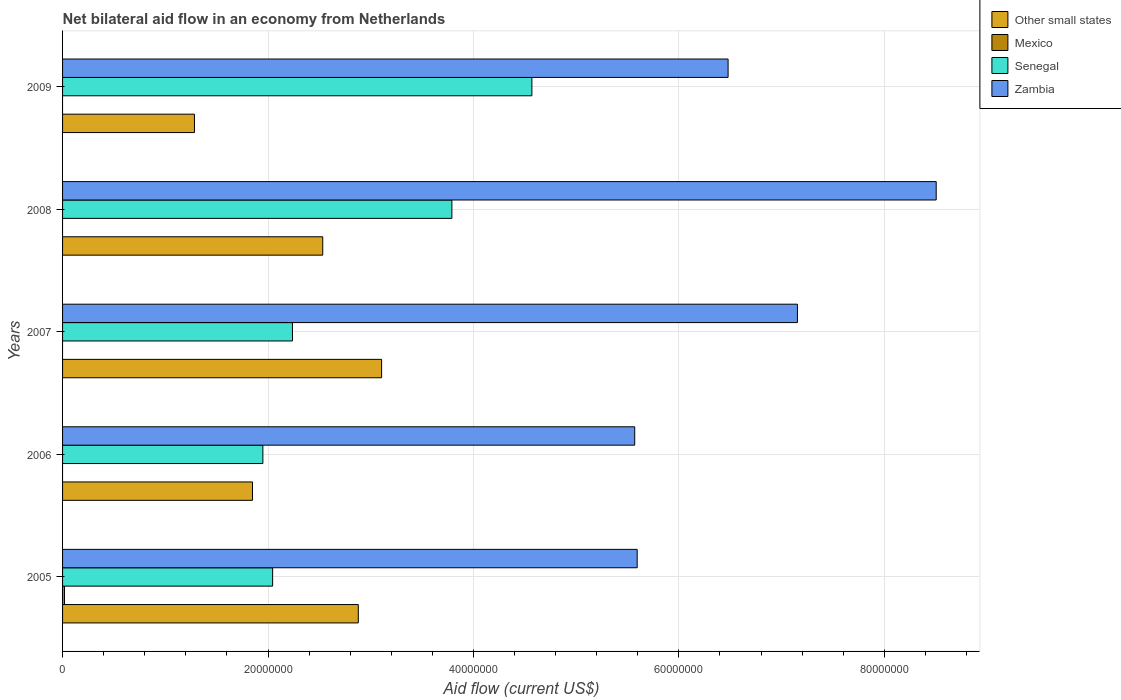Are the number of bars per tick equal to the number of legend labels?
Give a very brief answer. No. Are the number of bars on each tick of the Y-axis equal?
Ensure brevity in your answer.  No. In how many cases, is the number of bars for a given year not equal to the number of legend labels?
Make the answer very short. 4. Across all years, what is the maximum net bilateral aid flow in Mexico?
Give a very brief answer. 1.90e+05. Across all years, what is the minimum net bilateral aid flow in Mexico?
Your answer should be compact. 0. What is the total net bilateral aid flow in Senegal in the graph?
Give a very brief answer. 1.46e+08. What is the difference between the net bilateral aid flow in Zambia in 2005 and that in 2006?
Make the answer very short. 2.40e+05. What is the difference between the net bilateral aid flow in Zambia in 2006 and the net bilateral aid flow in Senegal in 2005?
Provide a succinct answer. 3.52e+07. What is the average net bilateral aid flow in Senegal per year?
Keep it short and to the point. 2.92e+07. In the year 2005, what is the difference between the net bilateral aid flow in Other small states and net bilateral aid flow in Senegal?
Keep it short and to the point. 8.34e+06. In how many years, is the net bilateral aid flow in Senegal greater than 40000000 US$?
Provide a short and direct response. 1. What is the ratio of the net bilateral aid flow in Senegal in 2005 to that in 2009?
Provide a short and direct response. 0.45. Is the net bilateral aid flow in Senegal in 2006 less than that in 2008?
Give a very brief answer. Yes. What is the difference between the highest and the second highest net bilateral aid flow in Zambia?
Ensure brevity in your answer.  1.35e+07. What is the difference between the highest and the lowest net bilateral aid flow in Senegal?
Ensure brevity in your answer.  2.62e+07. Is the sum of the net bilateral aid flow in Senegal in 2005 and 2006 greater than the maximum net bilateral aid flow in Mexico across all years?
Keep it short and to the point. Yes. Is it the case that in every year, the sum of the net bilateral aid flow in Mexico and net bilateral aid flow in Other small states is greater than the net bilateral aid flow in Senegal?
Make the answer very short. No. Are all the bars in the graph horizontal?
Keep it short and to the point. Yes. Does the graph contain any zero values?
Your response must be concise. Yes. How many legend labels are there?
Give a very brief answer. 4. How are the legend labels stacked?
Your answer should be very brief. Vertical. What is the title of the graph?
Keep it short and to the point. Net bilateral aid flow in an economy from Netherlands. Does "Guatemala" appear as one of the legend labels in the graph?
Your response must be concise. No. What is the label or title of the X-axis?
Provide a short and direct response. Aid flow (current US$). What is the Aid flow (current US$) in Other small states in 2005?
Your answer should be very brief. 2.88e+07. What is the Aid flow (current US$) of Mexico in 2005?
Keep it short and to the point. 1.90e+05. What is the Aid flow (current US$) of Senegal in 2005?
Provide a short and direct response. 2.04e+07. What is the Aid flow (current US$) of Zambia in 2005?
Provide a short and direct response. 5.59e+07. What is the Aid flow (current US$) of Other small states in 2006?
Your response must be concise. 1.85e+07. What is the Aid flow (current US$) in Senegal in 2006?
Keep it short and to the point. 1.95e+07. What is the Aid flow (current US$) of Zambia in 2006?
Your answer should be compact. 5.57e+07. What is the Aid flow (current US$) in Other small states in 2007?
Make the answer very short. 3.11e+07. What is the Aid flow (current US$) of Senegal in 2007?
Provide a short and direct response. 2.24e+07. What is the Aid flow (current US$) in Zambia in 2007?
Provide a succinct answer. 7.15e+07. What is the Aid flow (current US$) in Other small states in 2008?
Your response must be concise. 2.53e+07. What is the Aid flow (current US$) of Mexico in 2008?
Give a very brief answer. 0. What is the Aid flow (current US$) of Senegal in 2008?
Provide a succinct answer. 3.79e+07. What is the Aid flow (current US$) of Zambia in 2008?
Offer a very short reply. 8.50e+07. What is the Aid flow (current US$) in Other small states in 2009?
Ensure brevity in your answer.  1.28e+07. What is the Aid flow (current US$) of Senegal in 2009?
Ensure brevity in your answer.  4.57e+07. What is the Aid flow (current US$) of Zambia in 2009?
Offer a terse response. 6.48e+07. Across all years, what is the maximum Aid flow (current US$) in Other small states?
Provide a short and direct response. 3.11e+07. Across all years, what is the maximum Aid flow (current US$) in Mexico?
Your answer should be very brief. 1.90e+05. Across all years, what is the maximum Aid flow (current US$) of Senegal?
Provide a short and direct response. 4.57e+07. Across all years, what is the maximum Aid flow (current US$) of Zambia?
Offer a terse response. 8.50e+07. Across all years, what is the minimum Aid flow (current US$) in Other small states?
Keep it short and to the point. 1.28e+07. Across all years, what is the minimum Aid flow (current US$) in Mexico?
Your answer should be very brief. 0. Across all years, what is the minimum Aid flow (current US$) of Senegal?
Offer a terse response. 1.95e+07. Across all years, what is the minimum Aid flow (current US$) in Zambia?
Keep it short and to the point. 5.57e+07. What is the total Aid flow (current US$) in Other small states in the graph?
Provide a succinct answer. 1.17e+08. What is the total Aid flow (current US$) of Senegal in the graph?
Give a very brief answer. 1.46e+08. What is the total Aid flow (current US$) of Zambia in the graph?
Make the answer very short. 3.33e+08. What is the difference between the Aid flow (current US$) in Other small states in 2005 and that in 2006?
Provide a short and direct response. 1.03e+07. What is the difference between the Aid flow (current US$) of Senegal in 2005 and that in 2006?
Provide a short and direct response. 9.50e+05. What is the difference between the Aid flow (current US$) of Zambia in 2005 and that in 2006?
Your response must be concise. 2.40e+05. What is the difference between the Aid flow (current US$) of Other small states in 2005 and that in 2007?
Ensure brevity in your answer.  -2.27e+06. What is the difference between the Aid flow (current US$) in Senegal in 2005 and that in 2007?
Your answer should be compact. -1.93e+06. What is the difference between the Aid flow (current US$) in Zambia in 2005 and that in 2007?
Your answer should be very brief. -1.56e+07. What is the difference between the Aid flow (current US$) in Other small states in 2005 and that in 2008?
Ensure brevity in your answer.  3.46e+06. What is the difference between the Aid flow (current US$) in Senegal in 2005 and that in 2008?
Provide a short and direct response. -1.74e+07. What is the difference between the Aid flow (current US$) of Zambia in 2005 and that in 2008?
Your answer should be very brief. -2.91e+07. What is the difference between the Aid flow (current US$) in Other small states in 2005 and that in 2009?
Offer a very short reply. 1.60e+07. What is the difference between the Aid flow (current US$) in Senegal in 2005 and that in 2009?
Ensure brevity in your answer.  -2.52e+07. What is the difference between the Aid flow (current US$) of Zambia in 2005 and that in 2009?
Ensure brevity in your answer.  -8.85e+06. What is the difference between the Aid flow (current US$) in Other small states in 2006 and that in 2007?
Your response must be concise. -1.26e+07. What is the difference between the Aid flow (current US$) in Senegal in 2006 and that in 2007?
Your response must be concise. -2.88e+06. What is the difference between the Aid flow (current US$) of Zambia in 2006 and that in 2007?
Keep it short and to the point. -1.58e+07. What is the difference between the Aid flow (current US$) of Other small states in 2006 and that in 2008?
Make the answer very short. -6.84e+06. What is the difference between the Aid flow (current US$) in Senegal in 2006 and that in 2008?
Your answer should be compact. -1.84e+07. What is the difference between the Aid flow (current US$) in Zambia in 2006 and that in 2008?
Your response must be concise. -2.94e+07. What is the difference between the Aid flow (current US$) in Other small states in 2006 and that in 2009?
Give a very brief answer. 5.65e+06. What is the difference between the Aid flow (current US$) in Senegal in 2006 and that in 2009?
Offer a very short reply. -2.62e+07. What is the difference between the Aid flow (current US$) of Zambia in 2006 and that in 2009?
Offer a terse response. -9.09e+06. What is the difference between the Aid flow (current US$) in Other small states in 2007 and that in 2008?
Your answer should be compact. 5.73e+06. What is the difference between the Aid flow (current US$) in Senegal in 2007 and that in 2008?
Offer a very short reply. -1.55e+07. What is the difference between the Aid flow (current US$) in Zambia in 2007 and that in 2008?
Offer a very short reply. -1.35e+07. What is the difference between the Aid flow (current US$) in Other small states in 2007 and that in 2009?
Provide a short and direct response. 1.82e+07. What is the difference between the Aid flow (current US$) in Senegal in 2007 and that in 2009?
Your answer should be very brief. -2.33e+07. What is the difference between the Aid flow (current US$) of Zambia in 2007 and that in 2009?
Ensure brevity in your answer.  6.75e+06. What is the difference between the Aid flow (current US$) of Other small states in 2008 and that in 2009?
Ensure brevity in your answer.  1.25e+07. What is the difference between the Aid flow (current US$) of Senegal in 2008 and that in 2009?
Make the answer very short. -7.79e+06. What is the difference between the Aid flow (current US$) in Zambia in 2008 and that in 2009?
Keep it short and to the point. 2.03e+07. What is the difference between the Aid flow (current US$) of Other small states in 2005 and the Aid flow (current US$) of Senegal in 2006?
Keep it short and to the point. 9.29e+06. What is the difference between the Aid flow (current US$) of Other small states in 2005 and the Aid flow (current US$) of Zambia in 2006?
Your answer should be very brief. -2.69e+07. What is the difference between the Aid flow (current US$) of Mexico in 2005 and the Aid flow (current US$) of Senegal in 2006?
Provide a short and direct response. -1.93e+07. What is the difference between the Aid flow (current US$) of Mexico in 2005 and the Aid flow (current US$) of Zambia in 2006?
Offer a terse response. -5.55e+07. What is the difference between the Aid flow (current US$) of Senegal in 2005 and the Aid flow (current US$) of Zambia in 2006?
Provide a short and direct response. -3.52e+07. What is the difference between the Aid flow (current US$) of Other small states in 2005 and the Aid flow (current US$) of Senegal in 2007?
Provide a succinct answer. 6.41e+06. What is the difference between the Aid flow (current US$) in Other small states in 2005 and the Aid flow (current US$) in Zambia in 2007?
Keep it short and to the point. -4.28e+07. What is the difference between the Aid flow (current US$) in Mexico in 2005 and the Aid flow (current US$) in Senegal in 2007?
Make the answer very short. -2.22e+07. What is the difference between the Aid flow (current US$) of Mexico in 2005 and the Aid flow (current US$) of Zambia in 2007?
Give a very brief answer. -7.14e+07. What is the difference between the Aid flow (current US$) of Senegal in 2005 and the Aid flow (current US$) of Zambia in 2007?
Your answer should be very brief. -5.11e+07. What is the difference between the Aid flow (current US$) in Other small states in 2005 and the Aid flow (current US$) in Senegal in 2008?
Provide a succinct answer. -9.11e+06. What is the difference between the Aid flow (current US$) of Other small states in 2005 and the Aid flow (current US$) of Zambia in 2008?
Your answer should be very brief. -5.63e+07. What is the difference between the Aid flow (current US$) of Mexico in 2005 and the Aid flow (current US$) of Senegal in 2008?
Offer a terse response. -3.77e+07. What is the difference between the Aid flow (current US$) in Mexico in 2005 and the Aid flow (current US$) in Zambia in 2008?
Ensure brevity in your answer.  -8.49e+07. What is the difference between the Aid flow (current US$) in Senegal in 2005 and the Aid flow (current US$) in Zambia in 2008?
Your answer should be compact. -6.46e+07. What is the difference between the Aid flow (current US$) of Other small states in 2005 and the Aid flow (current US$) of Senegal in 2009?
Your answer should be very brief. -1.69e+07. What is the difference between the Aid flow (current US$) in Other small states in 2005 and the Aid flow (current US$) in Zambia in 2009?
Keep it short and to the point. -3.60e+07. What is the difference between the Aid flow (current US$) in Mexico in 2005 and the Aid flow (current US$) in Senegal in 2009?
Offer a terse response. -4.55e+07. What is the difference between the Aid flow (current US$) in Mexico in 2005 and the Aid flow (current US$) in Zambia in 2009?
Provide a short and direct response. -6.46e+07. What is the difference between the Aid flow (current US$) of Senegal in 2005 and the Aid flow (current US$) of Zambia in 2009?
Provide a short and direct response. -4.43e+07. What is the difference between the Aid flow (current US$) in Other small states in 2006 and the Aid flow (current US$) in Senegal in 2007?
Ensure brevity in your answer.  -3.89e+06. What is the difference between the Aid flow (current US$) in Other small states in 2006 and the Aid flow (current US$) in Zambia in 2007?
Your answer should be compact. -5.30e+07. What is the difference between the Aid flow (current US$) of Senegal in 2006 and the Aid flow (current US$) of Zambia in 2007?
Offer a terse response. -5.20e+07. What is the difference between the Aid flow (current US$) of Other small states in 2006 and the Aid flow (current US$) of Senegal in 2008?
Ensure brevity in your answer.  -1.94e+07. What is the difference between the Aid flow (current US$) of Other small states in 2006 and the Aid flow (current US$) of Zambia in 2008?
Offer a very short reply. -6.66e+07. What is the difference between the Aid flow (current US$) in Senegal in 2006 and the Aid flow (current US$) in Zambia in 2008?
Your answer should be very brief. -6.56e+07. What is the difference between the Aid flow (current US$) in Other small states in 2006 and the Aid flow (current US$) in Senegal in 2009?
Make the answer very short. -2.72e+07. What is the difference between the Aid flow (current US$) of Other small states in 2006 and the Aid flow (current US$) of Zambia in 2009?
Offer a terse response. -4.63e+07. What is the difference between the Aid flow (current US$) of Senegal in 2006 and the Aid flow (current US$) of Zambia in 2009?
Ensure brevity in your answer.  -4.53e+07. What is the difference between the Aid flow (current US$) of Other small states in 2007 and the Aid flow (current US$) of Senegal in 2008?
Offer a very short reply. -6.84e+06. What is the difference between the Aid flow (current US$) of Other small states in 2007 and the Aid flow (current US$) of Zambia in 2008?
Offer a terse response. -5.40e+07. What is the difference between the Aid flow (current US$) of Senegal in 2007 and the Aid flow (current US$) of Zambia in 2008?
Keep it short and to the point. -6.27e+07. What is the difference between the Aid flow (current US$) in Other small states in 2007 and the Aid flow (current US$) in Senegal in 2009?
Make the answer very short. -1.46e+07. What is the difference between the Aid flow (current US$) in Other small states in 2007 and the Aid flow (current US$) in Zambia in 2009?
Provide a short and direct response. -3.37e+07. What is the difference between the Aid flow (current US$) of Senegal in 2007 and the Aid flow (current US$) of Zambia in 2009?
Provide a succinct answer. -4.24e+07. What is the difference between the Aid flow (current US$) of Other small states in 2008 and the Aid flow (current US$) of Senegal in 2009?
Your response must be concise. -2.04e+07. What is the difference between the Aid flow (current US$) in Other small states in 2008 and the Aid flow (current US$) in Zambia in 2009?
Your answer should be very brief. -3.95e+07. What is the difference between the Aid flow (current US$) in Senegal in 2008 and the Aid flow (current US$) in Zambia in 2009?
Make the answer very short. -2.69e+07. What is the average Aid flow (current US$) of Other small states per year?
Your response must be concise. 2.33e+07. What is the average Aid flow (current US$) in Mexico per year?
Your answer should be compact. 3.80e+04. What is the average Aid flow (current US$) in Senegal per year?
Make the answer very short. 2.92e+07. What is the average Aid flow (current US$) in Zambia per year?
Your response must be concise. 6.66e+07. In the year 2005, what is the difference between the Aid flow (current US$) in Other small states and Aid flow (current US$) in Mexico?
Your answer should be very brief. 2.86e+07. In the year 2005, what is the difference between the Aid flow (current US$) in Other small states and Aid flow (current US$) in Senegal?
Offer a terse response. 8.34e+06. In the year 2005, what is the difference between the Aid flow (current US$) in Other small states and Aid flow (current US$) in Zambia?
Give a very brief answer. -2.72e+07. In the year 2005, what is the difference between the Aid flow (current US$) in Mexico and Aid flow (current US$) in Senegal?
Provide a succinct answer. -2.03e+07. In the year 2005, what is the difference between the Aid flow (current US$) in Mexico and Aid flow (current US$) in Zambia?
Offer a very short reply. -5.58e+07. In the year 2005, what is the difference between the Aid flow (current US$) in Senegal and Aid flow (current US$) in Zambia?
Give a very brief answer. -3.55e+07. In the year 2006, what is the difference between the Aid flow (current US$) in Other small states and Aid flow (current US$) in Senegal?
Make the answer very short. -1.01e+06. In the year 2006, what is the difference between the Aid flow (current US$) in Other small states and Aid flow (current US$) in Zambia?
Your answer should be compact. -3.72e+07. In the year 2006, what is the difference between the Aid flow (current US$) of Senegal and Aid flow (current US$) of Zambia?
Give a very brief answer. -3.62e+07. In the year 2007, what is the difference between the Aid flow (current US$) in Other small states and Aid flow (current US$) in Senegal?
Your answer should be very brief. 8.68e+06. In the year 2007, what is the difference between the Aid flow (current US$) of Other small states and Aid flow (current US$) of Zambia?
Provide a succinct answer. -4.05e+07. In the year 2007, what is the difference between the Aid flow (current US$) of Senegal and Aid flow (current US$) of Zambia?
Offer a terse response. -4.92e+07. In the year 2008, what is the difference between the Aid flow (current US$) in Other small states and Aid flow (current US$) in Senegal?
Provide a succinct answer. -1.26e+07. In the year 2008, what is the difference between the Aid flow (current US$) in Other small states and Aid flow (current US$) in Zambia?
Keep it short and to the point. -5.97e+07. In the year 2008, what is the difference between the Aid flow (current US$) of Senegal and Aid flow (current US$) of Zambia?
Provide a succinct answer. -4.72e+07. In the year 2009, what is the difference between the Aid flow (current US$) in Other small states and Aid flow (current US$) in Senegal?
Ensure brevity in your answer.  -3.28e+07. In the year 2009, what is the difference between the Aid flow (current US$) in Other small states and Aid flow (current US$) in Zambia?
Ensure brevity in your answer.  -5.20e+07. In the year 2009, what is the difference between the Aid flow (current US$) in Senegal and Aid flow (current US$) in Zambia?
Your answer should be compact. -1.91e+07. What is the ratio of the Aid flow (current US$) of Other small states in 2005 to that in 2006?
Keep it short and to the point. 1.56. What is the ratio of the Aid flow (current US$) of Senegal in 2005 to that in 2006?
Provide a short and direct response. 1.05. What is the ratio of the Aid flow (current US$) in Other small states in 2005 to that in 2007?
Provide a short and direct response. 0.93. What is the ratio of the Aid flow (current US$) in Senegal in 2005 to that in 2007?
Ensure brevity in your answer.  0.91. What is the ratio of the Aid flow (current US$) of Zambia in 2005 to that in 2007?
Provide a short and direct response. 0.78. What is the ratio of the Aid flow (current US$) in Other small states in 2005 to that in 2008?
Provide a short and direct response. 1.14. What is the ratio of the Aid flow (current US$) in Senegal in 2005 to that in 2008?
Ensure brevity in your answer.  0.54. What is the ratio of the Aid flow (current US$) of Zambia in 2005 to that in 2008?
Offer a very short reply. 0.66. What is the ratio of the Aid flow (current US$) in Other small states in 2005 to that in 2009?
Make the answer very short. 2.24. What is the ratio of the Aid flow (current US$) in Senegal in 2005 to that in 2009?
Ensure brevity in your answer.  0.45. What is the ratio of the Aid flow (current US$) in Zambia in 2005 to that in 2009?
Make the answer very short. 0.86. What is the ratio of the Aid flow (current US$) in Other small states in 2006 to that in 2007?
Your answer should be very brief. 0.6. What is the ratio of the Aid flow (current US$) in Senegal in 2006 to that in 2007?
Give a very brief answer. 0.87. What is the ratio of the Aid flow (current US$) of Zambia in 2006 to that in 2007?
Your answer should be very brief. 0.78. What is the ratio of the Aid flow (current US$) of Other small states in 2006 to that in 2008?
Offer a terse response. 0.73. What is the ratio of the Aid flow (current US$) of Senegal in 2006 to that in 2008?
Ensure brevity in your answer.  0.51. What is the ratio of the Aid flow (current US$) in Zambia in 2006 to that in 2008?
Keep it short and to the point. 0.65. What is the ratio of the Aid flow (current US$) of Other small states in 2006 to that in 2009?
Ensure brevity in your answer.  1.44. What is the ratio of the Aid flow (current US$) in Senegal in 2006 to that in 2009?
Provide a succinct answer. 0.43. What is the ratio of the Aid flow (current US$) in Zambia in 2006 to that in 2009?
Give a very brief answer. 0.86. What is the ratio of the Aid flow (current US$) in Other small states in 2007 to that in 2008?
Your response must be concise. 1.23. What is the ratio of the Aid flow (current US$) of Senegal in 2007 to that in 2008?
Give a very brief answer. 0.59. What is the ratio of the Aid flow (current US$) in Zambia in 2007 to that in 2008?
Your response must be concise. 0.84. What is the ratio of the Aid flow (current US$) in Other small states in 2007 to that in 2009?
Offer a terse response. 2.42. What is the ratio of the Aid flow (current US$) of Senegal in 2007 to that in 2009?
Provide a short and direct response. 0.49. What is the ratio of the Aid flow (current US$) in Zambia in 2007 to that in 2009?
Offer a terse response. 1.1. What is the ratio of the Aid flow (current US$) in Other small states in 2008 to that in 2009?
Keep it short and to the point. 1.97. What is the ratio of the Aid flow (current US$) in Senegal in 2008 to that in 2009?
Give a very brief answer. 0.83. What is the ratio of the Aid flow (current US$) in Zambia in 2008 to that in 2009?
Keep it short and to the point. 1.31. What is the difference between the highest and the second highest Aid flow (current US$) in Other small states?
Keep it short and to the point. 2.27e+06. What is the difference between the highest and the second highest Aid flow (current US$) in Senegal?
Your answer should be compact. 7.79e+06. What is the difference between the highest and the second highest Aid flow (current US$) in Zambia?
Ensure brevity in your answer.  1.35e+07. What is the difference between the highest and the lowest Aid flow (current US$) in Other small states?
Provide a succinct answer. 1.82e+07. What is the difference between the highest and the lowest Aid flow (current US$) of Senegal?
Give a very brief answer. 2.62e+07. What is the difference between the highest and the lowest Aid flow (current US$) in Zambia?
Your response must be concise. 2.94e+07. 